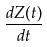<formula> <loc_0><loc_0><loc_500><loc_500>\frac { d Z ( t ) } { d t }</formula> 